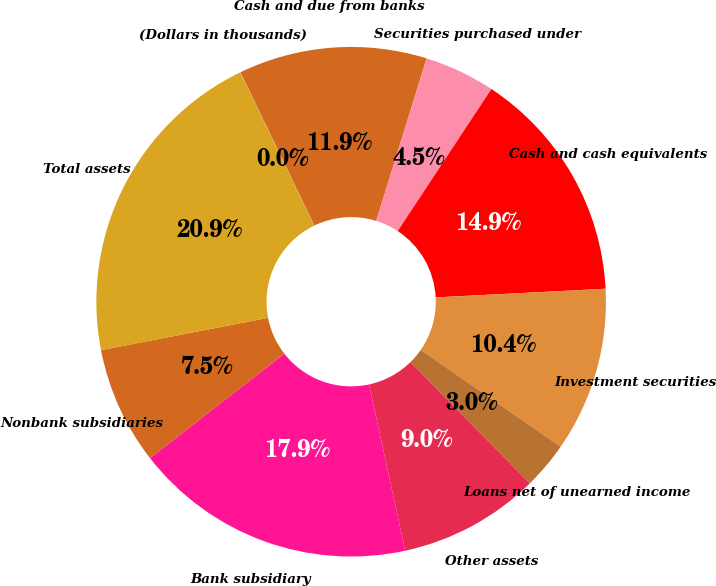Convert chart. <chart><loc_0><loc_0><loc_500><loc_500><pie_chart><fcel>(Dollars in thousands)<fcel>Cash and due from banks<fcel>Securities purchased under<fcel>Cash and cash equivalents<fcel>Investment securities<fcel>Loans net of unearned income<fcel>Other assets<fcel>Bank subsidiary<fcel>Nonbank subsidiaries<fcel>Total assets<nl><fcel>0.02%<fcel>11.94%<fcel>4.49%<fcel>14.91%<fcel>10.45%<fcel>3.0%<fcel>8.96%<fcel>17.89%<fcel>7.47%<fcel>20.87%<nl></chart> 